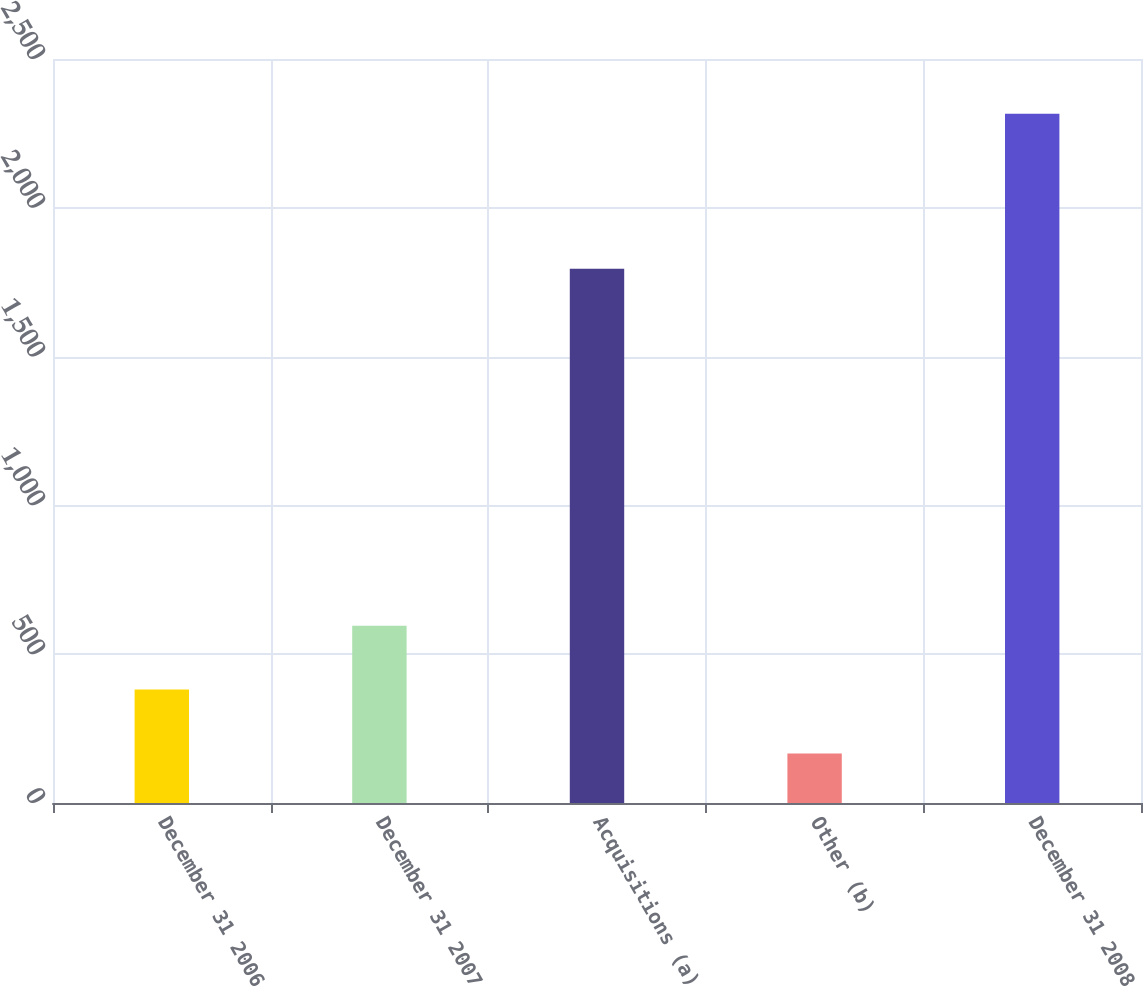<chart> <loc_0><loc_0><loc_500><loc_500><bar_chart><fcel>December 31 2006<fcel>December 31 2007<fcel>Acquisitions (a)<fcel>Other (b)<fcel>December 31 2008<nl><fcel>381<fcel>596<fcel>1795<fcel>166<fcel>2316<nl></chart> 